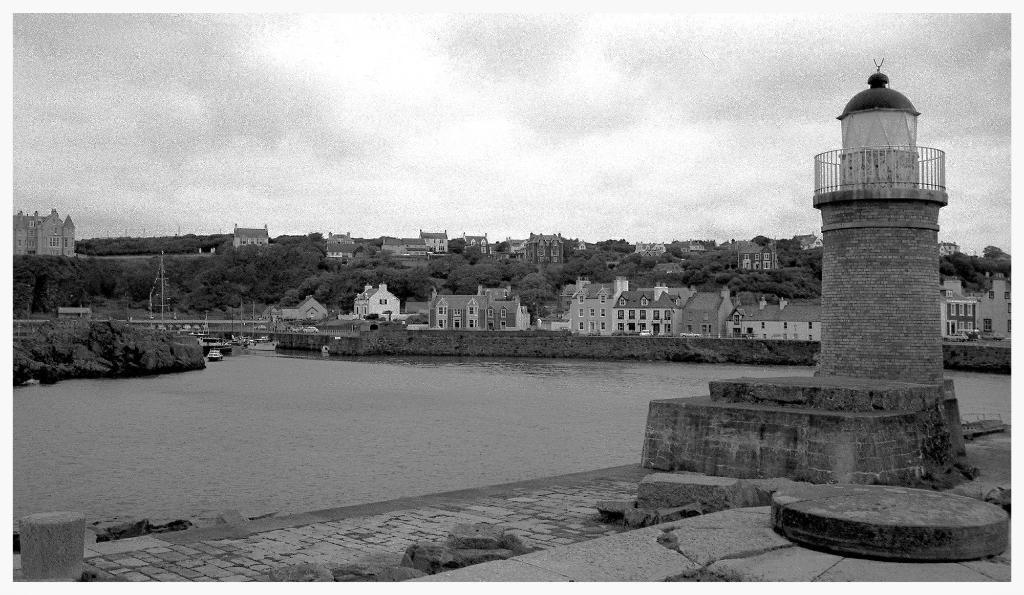What is located in the center of the image? There is water in the center of the image. What structure can be seen on the right side of the image? There is a lighthouse on the right side of the image. What can be seen in the background of the image? There are buildings, trees, and the sky visible in the background of the image. Where is the cable located in the image? There is no cable present in the image. What type of books can be found in the library depicted in the image? There is no library present in the image. 